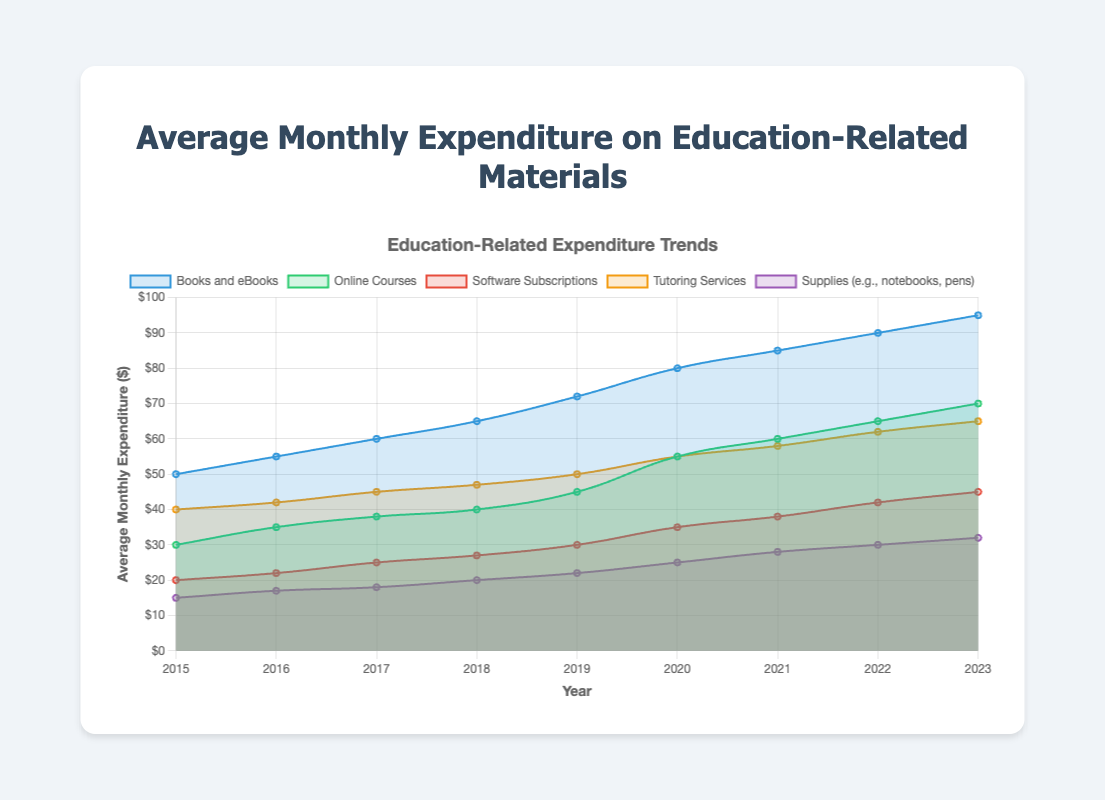What was the expenditure on Books and eBooks in 2017? Look for the data point associated with Books and eBooks in the year 2017 on the plot.
Answer: $60 In which year did Online Courses see the largest increase in expenditure compared to the previous year? Compare the yearly expenditure values for Online Courses and identify the largest difference between consecutive years. From 2019 to 2020, the increase was from $45 to $55, which is the largest increase of $10.
Answer: 2020 Which category had the highest total expenditure in 2023? Add up the expenditure values for each category in 2023 and compare the sums. Books and eBooks had the highest expenditure at $95.
Answer: Books and eBooks How much more was spent on Tutoring Services compared to Software Subscriptions in 2021? Find the expenditure values for both Tutoring Services and Software Subscriptions in 2021 and calculate the difference. $58 - $38 = $20.
Answer: $20 Which category had the lowest expenditure in 2019? Look at the expenditure values for each category in 2019 and identify the lowest one. Supplies (e.g., notebooks, pens) had the lowest expenditure at $22.
Answer: Supplies (e.g., notebooks, pens) Did the expenditure on Supplies increase or decrease over the years, and by how much from 2015 to 2023? Compare the expenditure values for Supplies in 2015 and 2023 and determine the difference. 2015 had $15, and 2023 had $32, thus an increase of $17.
Answer: Increased by $17 What is the average expenditure on Software Subscriptions over the entire period? Calculate the average by summing up the expenditure values for Software Subscriptions from 2015 to 2023 and then dividing by the number of years (9). (20 + 22 + 25 + 27 + 30 + 35 + 38 + 42 + 45) / 9 = 30.4
Answer: $30.4 Which year had the highest overall expenditure across all categories? Sum up the expenditure values for all categories for each year and compare the totals to find the highest one.
Answer: 2023 How has the expenditure trend for Books and eBooks changed from 2015 to 2023, visually described? Visually observe the trend for Books and eBooks over the years. The line representing Books and eBooks shows a steady upward trend from $50 in 2015 to $95 in 2023.
Answer: Steadily increased Is there any category that shows a consistent upward trend without any declines over the years? Visually inspect the plot for each category line and check if there are any declines in expenditure over the years. Books and eBooks show a consistent upward trend without any decline.
Answer: Books and eBooks 